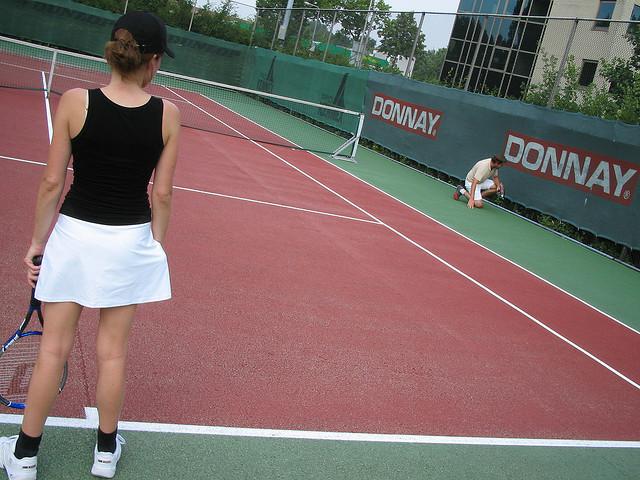What color is her skirt?
Keep it brief. White. Are they playing tennis?
Keep it brief. Yes. How many people are in this picture?
Concise answer only. 2. 